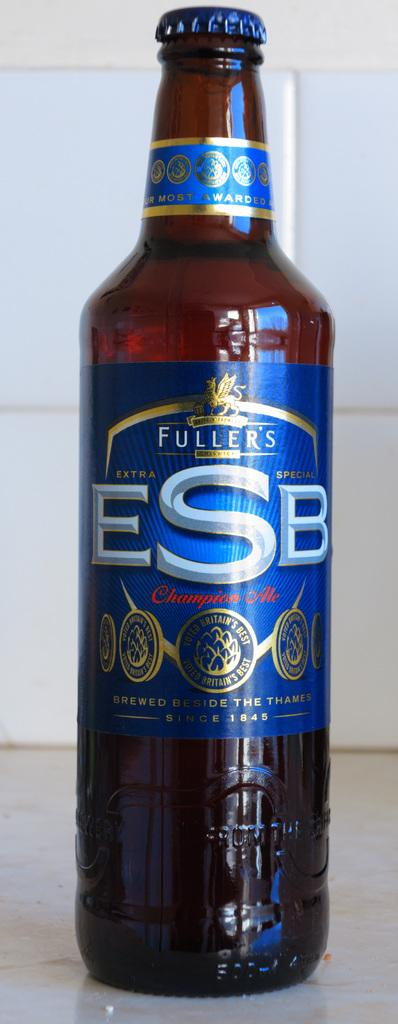<image>
Relay a brief, clear account of the picture shown. A bottle of Fuller's ESB with a blue and gold label. 